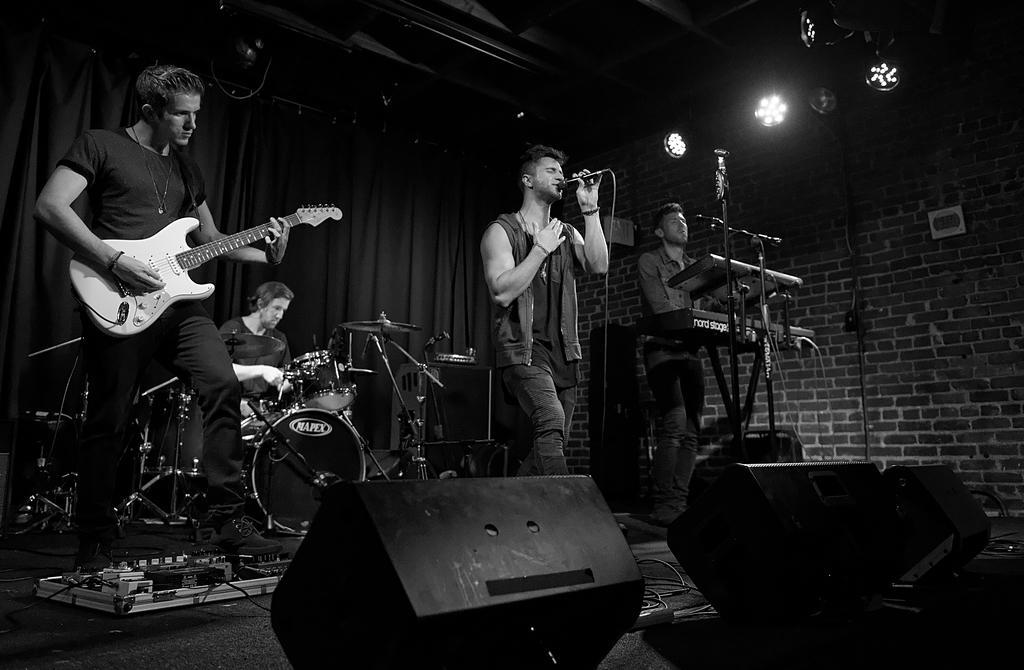In one or two sentences, can you explain what this image depicts? In this black and white picture there are few people standing. The man to the left corner is playing guitar. The man behind him is sitting and playing drums. The man to the right corner is playing keyboard. The man in the center is singing. He is holding a microphone in his hand. On the floor there are drums, drums stands, audio mixer, speakers and boxes. To the ceiling there are spotlights. In the background there is curtain and wall. 